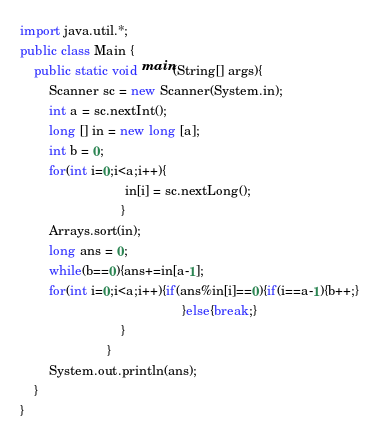Convert code to text. <code><loc_0><loc_0><loc_500><loc_500><_Java_>import java.util.*;
public class Main {
    public static void main(String[] args){
		Scanner sc = new Scanner(System.in);
		int a = sc.nextInt();
		long [] in = new long [a];
        int b = 0;
        for(int i=0;i<a;i++){
                             in[i] = sc.nextLong();
                            }
        Arrays.sort(in);
		long ans = 0;
        while(b==0){ans+=in[a-1];
        for(int i=0;i<a;i++){if(ans%in[i]==0){if(i==a-1){b++;}
                                             }else{break;}
                            }                             
                        }       
		System.out.println(ans);
	}
}
</code> 